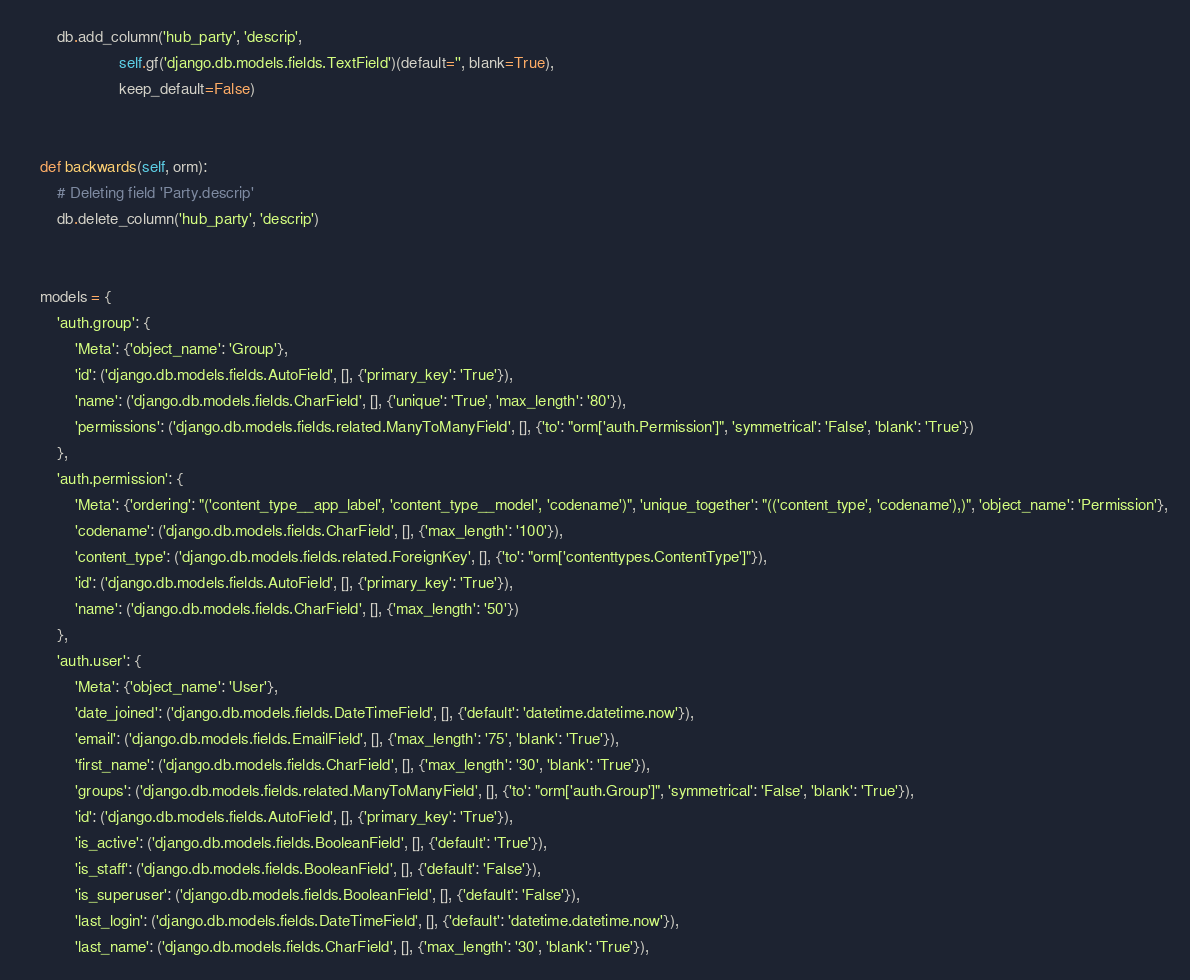Convert code to text. <code><loc_0><loc_0><loc_500><loc_500><_Python_>        db.add_column('hub_party', 'descrip',
                      self.gf('django.db.models.fields.TextField')(default='', blank=True),
                      keep_default=False)


    def backwards(self, orm):
        # Deleting field 'Party.descrip'
        db.delete_column('hub_party', 'descrip')


    models = {
        'auth.group': {
            'Meta': {'object_name': 'Group'},
            'id': ('django.db.models.fields.AutoField', [], {'primary_key': 'True'}),
            'name': ('django.db.models.fields.CharField', [], {'unique': 'True', 'max_length': '80'}),
            'permissions': ('django.db.models.fields.related.ManyToManyField', [], {'to': "orm['auth.Permission']", 'symmetrical': 'False', 'blank': 'True'})
        },
        'auth.permission': {
            'Meta': {'ordering': "('content_type__app_label', 'content_type__model', 'codename')", 'unique_together': "(('content_type', 'codename'),)", 'object_name': 'Permission'},
            'codename': ('django.db.models.fields.CharField', [], {'max_length': '100'}),
            'content_type': ('django.db.models.fields.related.ForeignKey', [], {'to': "orm['contenttypes.ContentType']"}),
            'id': ('django.db.models.fields.AutoField', [], {'primary_key': 'True'}),
            'name': ('django.db.models.fields.CharField', [], {'max_length': '50'})
        },
        'auth.user': {
            'Meta': {'object_name': 'User'},
            'date_joined': ('django.db.models.fields.DateTimeField', [], {'default': 'datetime.datetime.now'}),
            'email': ('django.db.models.fields.EmailField', [], {'max_length': '75', 'blank': 'True'}),
            'first_name': ('django.db.models.fields.CharField', [], {'max_length': '30', 'blank': 'True'}),
            'groups': ('django.db.models.fields.related.ManyToManyField', [], {'to': "orm['auth.Group']", 'symmetrical': 'False', 'blank': 'True'}),
            'id': ('django.db.models.fields.AutoField', [], {'primary_key': 'True'}),
            'is_active': ('django.db.models.fields.BooleanField', [], {'default': 'True'}),
            'is_staff': ('django.db.models.fields.BooleanField', [], {'default': 'False'}),
            'is_superuser': ('django.db.models.fields.BooleanField', [], {'default': 'False'}),
            'last_login': ('django.db.models.fields.DateTimeField', [], {'default': 'datetime.datetime.now'}),
            'last_name': ('django.db.models.fields.CharField', [], {'max_length': '30', 'blank': 'True'}),</code> 